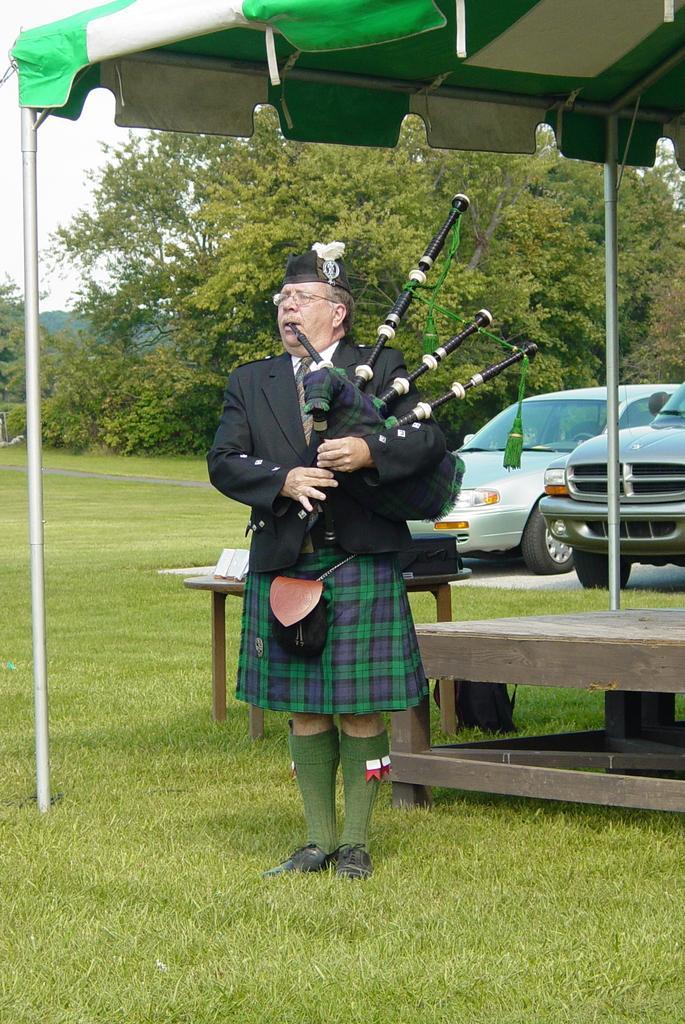Describe this image in one or two sentences. In this picture we can see a man wore a blazer, tie, spectacle, cap and holding a musical instrument with his hands and standing on the grass and at the back of him we can see a tent, tables, vehicles, trees and some objects and in the background we can see the sky. 